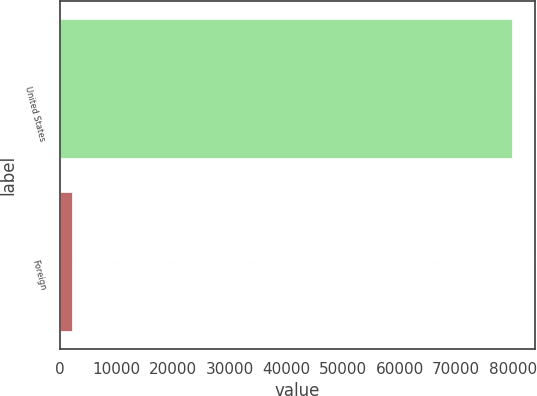<chart> <loc_0><loc_0><loc_500><loc_500><bar_chart><fcel>United States<fcel>Foreign<nl><fcel>79931<fcel>2257<nl></chart> 